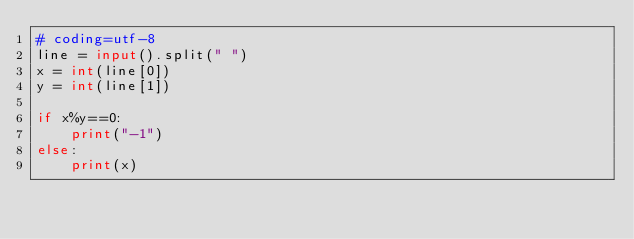Convert code to text. <code><loc_0><loc_0><loc_500><loc_500><_Python_># coding=utf-8
line = input().split(" ")
x = int(line[0])
y = int(line[1])

if x%y==0:
    print("-1")
else:
    print(x)
</code> 